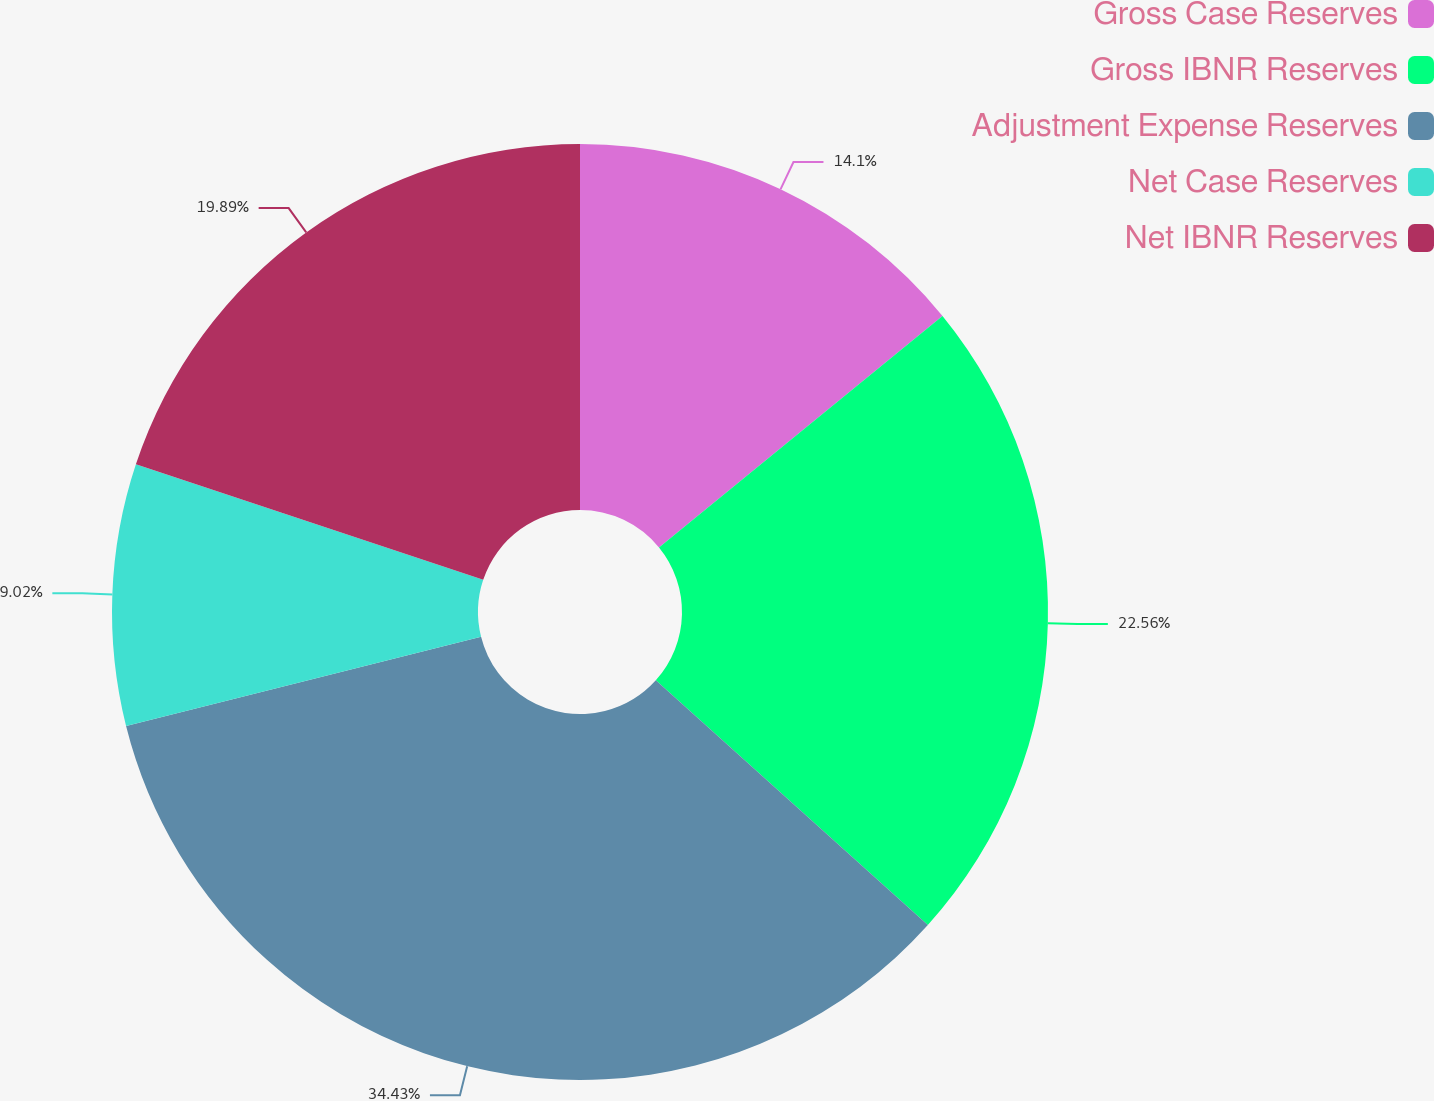Convert chart. <chart><loc_0><loc_0><loc_500><loc_500><pie_chart><fcel>Gross Case Reserves<fcel>Gross IBNR Reserves<fcel>Adjustment Expense Reserves<fcel>Net Case Reserves<fcel>Net IBNR Reserves<nl><fcel>14.1%<fcel>22.56%<fcel>34.42%<fcel>9.02%<fcel>19.89%<nl></chart> 